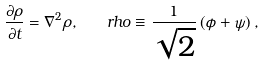<formula> <loc_0><loc_0><loc_500><loc_500>\frac { \partial \rho } { \partial t } = \nabla ^ { 2 } \rho , \quad r h o \equiv \frac { 1 } { \sqrt { 2 } } \left ( \phi + \psi \right ) ,</formula> 